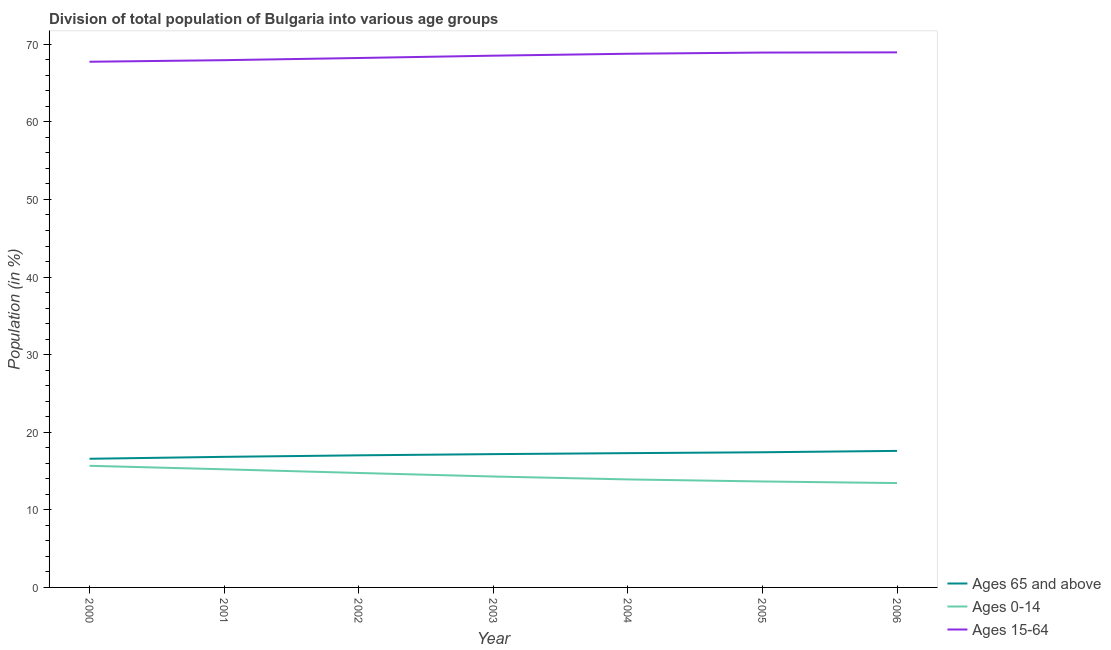Does the line corresponding to percentage of population within the age-group 0-14 intersect with the line corresponding to percentage of population within the age-group 15-64?
Your answer should be compact. No. What is the percentage of population within the age-group 0-14 in 2005?
Your response must be concise. 13.65. Across all years, what is the maximum percentage of population within the age-group of 65 and above?
Provide a short and direct response. 17.6. Across all years, what is the minimum percentage of population within the age-group of 65 and above?
Your response must be concise. 16.58. In which year was the percentage of population within the age-group 0-14 maximum?
Your answer should be very brief. 2000. What is the total percentage of population within the age-group 0-14 in the graph?
Offer a terse response. 100.96. What is the difference between the percentage of population within the age-group 0-14 in 2004 and that in 2006?
Your response must be concise. 0.47. What is the difference between the percentage of population within the age-group 0-14 in 2004 and the percentage of population within the age-group of 65 and above in 2000?
Your answer should be very brief. -2.66. What is the average percentage of population within the age-group of 65 and above per year?
Give a very brief answer. 17.13. In the year 2001, what is the difference between the percentage of population within the age-group 0-14 and percentage of population within the age-group of 65 and above?
Your response must be concise. -1.61. In how many years, is the percentage of population within the age-group 0-14 greater than 48 %?
Your answer should be compact. 0. What is the ratio of the percentage of population within the age-group 15-64 in 2003 to that in 2006?
Offer a terse response. 0.99. Is the percentage of population within the age-group 15-64 in 2003 less than that in 2004?
Ensure brevity in your answer.  Yes. Is the difference between the percentage of population within the age-group 15-64 in 2000 and 2006 greater than the difference between the percentage of population within the age-group 0-14 in 2000 and 2006?
Offer a very short reply. No. What is the difference between the highest and the second highest percentage of population within the age-group of 65 and above?
Your answer should be compact. 0.18. What is the difference between the highest and the lowest percentage of population within the age-group 0-14?
Your answer should be very brief. 2.22. Is it the case that in every year, the sum of the percentage of population within the age-group of 65 and above and percentage of population within the age-group 0-14 is greater than the percentage of population within the age-group 15-64?
Make the answer very short. No. Is the percentage of population within the age-group 0-14 strictly less than the percentage of population within the age-group of 65 and above over the years?
Your answer should be very brief. Yes. How many lines are there?
Your answer should be very brief. 3. How many years are there in the graph?
Offer a terse response. 7. What is the difference between two consecutive major ticks on the Y-axis?
Provide a short and direct response. 10. Are the values on the major ticks of Y-axis written in scientific E-notation?
Make the answer very short. No. What is the title of the graph?
Provide a short and direct response. Division of total population of Bulgaria into various age groups
. Does "Manufactures" appear as one of the legend labels in the graph?
Your answer should be very brief. No. What is the label or title of the X-axis?
Your answer should be very brief. Year. What is the Population (in %) in Ages 65 and above in 2000?
Ensure brevity in your answer.  16.58. What is the Population (in %) in Ages 0-14 in 2000?
Provide a short and direct response. 15.67. What is the Population (in %) in Ages 15-64 in 2000?
Offer a very short reply. 67.74. What is the Population (in %) of Ages 65 and above in 2001?
Your response must be concise. 16.83. What is the Population (in %) of Ages 0-14 in 2001?
Make the answer very short. 15.22. What is the Population (in %) of Ages 15-64 in 2001?
Ensure brevity in your answer.  67.95. What is the Population (in %) in Ages 65 and above in 2002?
Your answer should be compact. 17.02. What is the Population (in %) in Ages 0-14 in 2002?
Offer a terse response. 14.75. What is the Population (in %) of Ages 15-64 in 2002?
Provide a succinct answer. 68.23. What is the Population (in %) of Ages 65 and above in 2003?
Provide a succinct answer. 17.18. What is the Population (in %) in Ages 0-14 in 2003?
Keep it short and to the point. 14.29. What is the Population (in %) of Ages 15-64 in 2003?
Provide a succinct answer. 68.53. What is the Population (in %) in Ages 65 and above in 2004?
Keep it short and to the point. 17.31. What is the Population (in %) of Ages 0-14 in 2004?
Your answer should be very brief. 13.92. What is the Population (in %) of Ages 15-64 in 2004?
Offer a terse response. 68.78. What is the Population (in %) of Ages 65 and above in 2005?
Make the answer very short. 17.42. What is the Population (in %) in Ages 0-14 in 2005?
Keep it short and to the point. 13.65. What is the Population (in %) in Ages 15-64 in 2005?
Your answer should be compact. 68.93. What is the Population (in %) of Ages 65 and above in 2006?
Your answer should be compact. 17.6. What is the Population (in %) of Ages 0-14 in 2006?
Keep it short and to the point. 13.45. What is the Population (in %) in Ages 15-64 in 2006?
Keep it short and to the point. 68.95. Across all years, what is the maximum Population (in %) in Ages 65 and above?
Your response must be concise. 17.6. Across all years, what is the maximum Population (in %) in Ages 0-14?
Offer a very short reply. 15.67. Across all years, what is the maximum Population (in %) in Ages 15-64?
Your answer should be very brief. 68.95. Across all years, what is the minimum Population (in %) in Ages 65 and above?
Make the answer very short. 16.58. Across all years, what is the minimum Population (in %) in Ages 0-14?
Offer a terse response. 13.45. Across all years, what is the minimum Population (in %) in Ages 15-64?
Your answer should be very brief. 67.74. What is the total Population (in %) of Ages 65 and above in the graph?
Provide a succinct answer. 119.93. What is the total Population (in %) of Ages 0-14 in the graph?
Your response must be concise. 100.96. What is the total Population (in %) in Ages 15-64 in the graph?
Your answer should be very brief. 479.11. What is the difference between the Population (in %) in Ages 65 and above in 2000 and that in 2001?
Your response must be concise. -0.25. What is the difference between the Population (in %) of Ages 0-14 in 2000 and that in 2001?
Your answer should be compact. 0.45. What is the difference between the Population (in %) in Ages 15-64 in 2000 and that in 2001?
Ensure brevity in your answer.  -0.2. What is the difference between the Population (in %) of Ages 65 and above in 2000 and that in 2002?
Your response must be concise. -0.44. What is the difference between the Population (in %) of Ages 0-14 in 2000 and that in 2002?
Keep it short and to the point. 0.92. What is the difference between the Population (in %) in Ages 15-64 in 2000 and that in 2002?
Provide a short and direct response. -0.48. What is the difference between the Population (in %) in Ages 65 and above in 2000 and that in 2003?
Provide a succinct answer. -0.6. What is the difference between the Population (in %) in Ages 0-14 in 2000 and that in 2003?
Make the answer very short. 1.38. What is the difference between the Population (in %) of Ages 15-64 in 2000 and that in 2003?
Offer a very short reply. -0.78. What is the difference between the Population (in %) in Ages 65 and above in 2000 and that in 2004?
Provide a succinct answer. -0.72. What is the difference between the Population (in %) of Ages 0-14 in 2000 and that in 2004?
Keep it short and to the point. 1.75. What is the difference between the Population (in %) in Ages 15-64 in 2000 and that in 2004?
Keep it short and to the point. -1.03. What is the difference between the Population (in %) in Ages 65 and above in 2000 and that in 2005?
Provide a succinct answer. -0.84. What is the difference between the Population (in %) of Ages 0-14 in 2000 and that in 2005?
Make the answer very short. 2.02. What is the difference between the Population (in %) in Ages 15-64 in 2000 and that in 2005?
Offer a terse response. -1.18. What is the difference between the Population (in %) of Ages 65 and above in 2000 and that in 2006?
Your response must be concise. -1.01. What is the difference between the Population (in %) of Ages 0-14 in 2000 and that in 2006?
Provide a succinct answer. 2.22. What is the difference between the Population (in %) in Ages 15-64 in 2000 and that in 2006?
Keep it short and to the point. -1.21. What is the difference between the Population (in %) of Ages 65 and above in 2001 and that in 2002?
Offer a terse response. -0.19. What is the difference between the Population (in %) of Ages 0-14 in 2001 and that in 2002?
Give a very brief answer. 0.47. What is the difference between the Population (in %) of Ages 15-64 in 2001 and that in 2002?
Your response must be concise. -0.28. What is the difference between the Population (in %) in Ages 65 and above in 2001 and that in 2003?
Offer a terse response. -0.35. What is the difference between the Population (in %) in Ages 0-14 in 2001 and that in 2003?
Offer a terse response. 0.93. What is the difference between the Population (in %) of Ages 15-64 in 2001 and that in 2003?
Provide a short and direct response. -0.58. What is the difference between the Population (in %) of Ages 65 and above in 2001 and that in 2004?
Keep it short and to the point. -0.48. What is the difference between the Population (in %) in Ages 0-14 in 2001 and that in 2004?
Ensure brevity in your answer.  1.3. What is the difference between the Population (in %) of Ages 15-64 in 2001 and that in 2004?
Your answer should be very brief. -0.83. What is the difference between the Population (in %) of Ages 65 and above in 2001 and that in 2005?
Provide a short and direct response. -0.59. What is the difference between the Population (in %) in Ages 0-14 in 2001 and that in 2005?
Your response must be concise. 1.57. What is the difference between the Population (in %) in Ages 15-64 in 2001 and that in 2005?
Provide a short and direct response. -0.98. What is the difference between the Population (in %) in Ages 65 and above in 2001 and that in 2006?
Provide a succinct answer. -0.77. What is the difference between the Population (in %) of Ages 0-14 in 2001 and that in 2006?
Your answer should be compact. 1.77. What is the difference between the Population (in %) of Ages 15-64 in 2001 and that in 2006?
Provide a succinct answer. -1.01. What is the difference between the Population (in %) of Ages 65 and above in 2002 and that in 2003?
Provide a succinct answer. -0.16. What is the difference between the Population (in %) in Ages 0-14 in 2002 and that in 2003?
Keep it short and to the point. 0.46. What is the difference between the Population (in %) of Ages 15-64 in 2002 and that in 2003?
Provide a succinct answer. -0.3. What is the difference between the Population (in %) in Ages 65 and above in 2002 and that in 2004?
Your answer should be compact. -0.28. What is the difference between the Population (in %) in Ages 0-14 in 2002 and that in 2004?
Offer a terse response. 0.83. What is the difference between the Population (in %) of Ages 15-64 in 2002 and that in 2004?
Offer a very short reply. -0.55. What is the difference between the Population (in %) of Ages 65 and above in 2002 and that in 2005?
Offer a terse response. -0.4. What is the difference between the Population (in %) of Ages 0-14 in 2002 and that in 2005?
Offer a terse response. 1.1. What is the difference between the Population (in %) of Ages 15-64 in 2002 and that in 2005?
Your answer should be compact. -0.7. What is the difference between the Population (in %) of Ages 65 and above in 2002 and that in 2006?
Your answer should be very brief. -0.57. What is the difference between the Population (in %) in Ages 0-14 in 2002 and that in 2006?
Your response must be concise. 1.3. What is the difference between the Population (in %) in Ages 15-64 in 2002 and that in 2006?
Provide a succinct answer. -0.73. What is the difference between the Population (in %) in Ages 65 and above in 2003 and that in 2004?
Your answer should be compact. -0.13. What is the difference between the Population (in %) in Ages 0-14 in 2003 and that in 2004?
Your answer should be very brief. 0.38. What is the difference between the Population (in %) in Ages 15-64 in 2003 and that in 2004?
Your response must be concise. -0.25. What is the difference between the Population (in %) of Ages 65 and above in 2003 and that in 2005?
Give a very brief answer. -0.24. What is the difference between the Population (in %) of Ages 0-14 in 2003 and that in 2005?
Provide a short and direct response. 0.64. What is the difference between the Population (in %) of Ages 15-64 in 2003 and that in 2005?
Your answer should be very brief. -0.4. What is the difference between the Population (in %) in Ages 65 and above in 2003 and that in 2006?
Your answer should be compact. -0.42. What is the difference between the Population (in %) in Ages 0-14 in 2003 and that in 2006?
Give a very brief answer. 0.85. What is the difference between the Population (in %) in Ages 15-64 in 2003 and that in 2006?
Your response must be concise. -0.43. What is the difference between the Population (in %) in Ages 65 and above in 2004 and that in 2005?
Provide a succinct answer. -0.11. What is the difference between the Population (in %) in Ages 0-14 in 2004 and that in 2005?
Offer a very short reply. 0.26. What is the difference between the Population (in %) in Ages 15-64 in 2004 and that in 2005?
Your answer should be very brief. -0.15. What is the difference between the Population (in %) in Ages 65 and above in 2004 and that in 2006?
Your answer should be compact. -0.29. What is the difference between the Population (in %) in Ages 0-14 in 2004 and that in 2006?
Keep it short and to the point. 0.47. What is the difference between the Population (in %) of Ages 15-64 in 2004 and that in 2006?
Offer a very short reply. -0.18. What is the difference between the Population (in %) of Ages 65 and above in 2005 and that in 2006?
Provide a succinct answer. -0.18. What is the difference between the Population (in %) in Ages 0-14 in 2005 and that in 2006?
Provide a succinct answer. 0.2. What is the difference between the Population (in %) of Ages 15-64 in 2005 and that in 2006?
Offer a very short reply. -0.03. What is the difference between the Population (in %) in Ages 65 and above in 2000 and the Population (in %) in Ages 0-14 in 2001?
Make the answer very short. 1.36. What is the difference between the Population (in %) in Ages 65 and above in 2000 and the Population (in %) in Ages 15-64 in 2001?
Provide a short and direct response. -51.37. What is the difference between the Population (in %) in Ages 0-14 in 2000 and the Population (in %) in Ages 15-64 in 2001?
Your answer should be very brief. -52.27. What is the difference between the Population (in %) of Ages 65 and above in 2000 and the Population (in %) of Ages 0-14 in 2002?
Your answer should be very brief. 1.83. What is the difference between the Population (in %) in Ages 65 and above in 2000 and the Population (in %) in Ages 15-64 in 2002?
Give a very brief answer. -51.65. What is the difference between the Population (in %) in Ages 0-14 in 2000 and the Population (in %) in Ages 15-64 in 2002?
Offer a very short reply. -52.55. What is the difference between the Population (in %) of Ages 65 and above in 2000 and the Population (in %) of Ages 0-14 in 2003?
Make the answer very short. 2.29. What is the difference between the Population (in %) in Ages 65 and above in 2000 and the Population (in %) in Ages 15-64 in 2003?
Your answer should be very brief. -51.95. What is the difference between the Population (in %) in Ages 0-14 in 2000 and the Population (in %) in Ages 15-64 in 2003?
Offer a terse response. -52.85. What is the difference between the Population (in %) of Ages 65 and above in 2000 and the Population (in %) of Ages 0-14 in 2004?
Your answer should be compact. 2.66. What is the difference between the Population (in %) in Ages 65 and above in 2000 and the Population (in %) in Ages 15-64 in 2004?
Make the answer very short. -52.19. What is the difference between the Population (in %) of Ages 0-14 in 2000 and the Population (in %) of Ages 15-64 in 2004?
Your response must be concise. -53.1. What is the difference between the Population (in %) in Ages 65 and above in 2000 and the Population (in %) in Ages 0-14 in 2005?
Provide a succinct answer. 2.93. What is the difference between the Population (in %) of Ages 65 and above in 2000 and the Population (in %) of Ages 15-64 in 2005?
Your answer should be very brief. -52.35. What is the difference between the Population (in %) of Ages 0-14 in 2000 and the Population (in %) of Ages 15-64 in 2005?
Provide a succinct answer. -53.25. What is the difference between the Population (in %) of Ages 65 and above in 2000 and the Population (in %) of Ages 0-14 in 2006?
Offer a terse response. 3.13. What is the difference between the Population (in %) of Ages 65 and above in 2000 and the Population (in %) of Ages 15-64 in 2006?
Offer a terse response. -52.37. What is the difference between the Population (in %) in Ages 0-14 in 2000 and the Population (in %) in Ages 15-64 in 2006?
Make the answer very short. -53.28. What is the difference between the Population (in %) of Ages 65 and above in 2001 and the Population (in %) of Ages 0-14 in 2002?
Keep it short and to the point. 2.08. What is the difference between the Population (in %) of Ages 65 and above in 2001 and the Population (in %) of Ages 15-64 in 2002?
Ensure brevity in your answer.  -51.4. What is the difference between the Population (in %) in Ages 0-14 in 2001 and the Population (in %) in Ages 15-64 in 2002?
Your response must be concise. -53. What is the difference between the Population (in %) of Ages 65 and above in 2001 and the Population (in %) of Ages 0-14 in 2003?
Your response must be concise. 2.53. What is the difference between the Population (in %) of Ages 65 and above in 2001 and the Population (in %) of Ages 15-64 in 2003?
Keep it short and to the point. -51.7. What is the difference between the Population (in %) in Ages 0-14 in 2001 and the Population (in %) in Ages 15-64 in 2003?
Your answer should be very brief. -53.3. What is the difference between the Population (in %) of Ages 65 and above in 2001 and the Population (in %) of Ages 0-14 in 2004?
Give a very brief answer. 2.91. What is the difference between the Population (in %) in Ages 65 and above in 2001 and the Population (in %) in Ages 15-64 in 2004?
Give a very brief answer. -51.95. What is the difference between the Population (in %) in Ages 0-14 in 2001 and the Population (in %) in Ages 15-64 in 2004?
Ensure brevity in your answer.  -53.55. What is the difference between the Population (in %) in Ages 65 and above in 2001 and the Population (in %) in Ages 0-14 in 2005?
Offer a terse response. 3.17. What is the difference between the Population (in %) in Ages 65 and above in 2001 and the Population (in %) in Ages 15-64 in 2005?
Provide a short and direct response. -52.1. What is the difference between the Population (in %) in Ages 0-14 in 2001 and the Population (in %) in Ages 15-64 in 2005?
Offer a terse response. -53.71. What is the difference between the Population (in %) of Ages 65 and above in 2001 and the Population (in %) of Ages 0-14 in 2006?
Keep it short and to the point. 3.38. What is the difference between the Population (in %) of Ages 65 and above in 2001 and the Population (in %) of Ages 15-64 in 2006?
Give a very brief answer. -52.13. What is the difference between the Population (in %) of Ages 0-14 in 2001 and the Population (in %) of Ages 15-64 in 2006?
Keep it short and to the point. -53.73. What is the difference between the Population (in %) in Ages 65 and above in 2002 and the Population (in %) in Ages 0-14 in 2003?
Provide a short and direct response. 2.73. What is the difference between the Population (in %) of Ages 65 and above in 2002 and the Population (in %) of Ages 15-64 in 2003?
Offer a terse response. -51.5. What is the difference between the Population (in %) of Ages 0-14 in 2002 and the Population (in %) of Ages 15-64 in 2003?
Offer a very short reply. -53.78. What is the difference between the Population (in %) of Ages 65 and above in 2002 and the Population (in %) of Ages 0-14 in 2004?
Give a very brief answer. 3.1. What is the difference between the Population (in %) in Ages 65 and above in 2002 and the Population (in %) in Ages 15-64 in 2004?
Ensure brevity in your answer.  -51.75. What is the difference between the Population (in %) of Ages 0-14 in 2002 and the Population (in %) of Ages 15-64 in 2004?
Provide a succinct answer. -54.03. What is the difference between the Population (in %) in Ages 65 and above in 2002 and the Population (in %) in Ages 0-14 in 2005?
Ensure brevity in your answer.  3.37. What is the difference between the Population (in %) of Ages 65 and above in 2002 and the Population (in %) of Ages 15-64 in 2005?
Your answer should be compact. -51.91. What is the difference between the Population (in %) in Ages 0-14 in 2002 and the Population (in %) in Ages 15-64 in 2005?
Offer a very short reply. -54.18. What is the difference between the Population (in %) in Ages 65 and above in 2002 and the Population (in %) in Ages 0-14 in 2006?
Your response must be concise. 3.57. What is the difference between the Population (in %) in Ages 65 and above in 2002 and the Population (in %) in Ages 15-64 in 2006?
Offer a terse response. -51.93. What is the difference between the Population (in %) in Ages 0-14 in 2002 and the Population (in %) in Ages 15-64 in 2006?
Offer a terse response. -54.2. What is the difference between the Population (in %) in Ages 65 and above in 2003 and the Population (in %) in Ages 0-14 in 2004?
Your answer should be very brief. 3.26. What is the difference between the Population (in %) of Ages 65 and above in 2003 and the Population (in %) of Ages 15-64 in 2004?
Your answer should be very brief. -51.6. What is the difference between the Population (in %) of Ages 0-14 in 2003 and the Population (in %) of Ages 15-64 in 2004?
Your answer should be very brief. -54.48. What is the difference between the Population (in %) of Ages 65 and above in 2003 and the Population (in %) of Ages 0-14 in 2005?
Make the answer very short. 3.52. What is the difference between the Population (in %) of Ages 65 and above in 2003 and the Population (in %) of Ages 15-64 in 2005?
Offer a very short reply. -51.75. What is the difference between the Population (in %) of Ages 0-14 in 2003 and the Population (in %) of Ages 15-64 in 2005?
Ensure brevity in your answer.  -54.63. What is the difference between the Population (in %) in Ages 65 and above in 2003 and the Population (in %) in Ages 0-14 in 2006?
Ensure brevity in your answer.  3.73. What is the difference between the Population (in %) of Ages 65 and above in 2003 and the Population (in %) of Ages 15-64 in 2006?
Offer a terse response. -51.78. What is the difference between the Population (in %) in Ages 0-14 in 2003 and the Population (in %) in Ages 15-64 in 2006?
Offer a terse response. -54.66. What is the difference between the Population (in %) of Ages 65 and above in 2004 and the Population (in %) of Ages 0-14 in 2005?
Your answer should be very brief. 3.65. What is the difference between the Population (in %) of Ages 65 and above in 2004 and the Population (in %) of Ages 15-64 in 2005?
Give a very brief answer. -51.62. What is the difference between the Population (in %) of Ages 0-14 in 2004 and the Population (in %) of Ages 15-64 in 2005?
Ensure brevity in your answer.  -55.01. What is the difference between the Population (in %) of Ages 65 and above in 2004 and the Population (in %) of Ages 0-14 in 2006?
Provide a short and direct response. 3.86. What is the difference between the Population (in %) of Ages 65 and above in 2004 and the Population (in %) of Ages 15-64 in 2006?
Make the answer very short. -51.65. What is the difference between the Population (in %) in Ages 0-14 in 2004 and the Population (in %) in Ages 15-64 in 2006?
Your answer should be compact. -55.04. What is the difference between the Population (in %) of Ages 65 and above in 2005 and the Population (in %) of Ages 0-14 in 2006?
Offer a very short reply. 3.97. What is the difference between the Population (in %) in Ages 65 and above in 2005 and the Population (in %) in Ages 15-64 in 2006?
Give a very brief answer. -51.54. What is the difference between the Population (in %) in Ages 0-14 in 2005 and the Population (in %) in Ages 15-64 in 2006?
Offer a terse response. -55.3. What is the average Population (in %) of Ages 65 and above per year?
Provide a short and direct response. 17.13. What is the average Population (in %) of Ages 0-14 per year?
Offer a terse response. 14.42. What is the average Population (in %) in Ages 15-64 per year?
Your response must be concise. 68.44. In the year 2000, what is the difference between the Population (in %) in Ages 65 and above and Population (in %) in Ages 0-14?
Your answer should be very brief. 0.91. In the year 2000, what is the difference between the Population (in %) of Ages 65 and above and Population (in %) of Ages 15-64?
Your response must be concise. -51.16. In the year 2000, what is the difference between the Population (in %) in Ages 0-14 and Population (in %) in Ages 15-64?
Your answer should be compact. -52.07. In the year 2001, what is the difference between the Population (in %) of Ages 65 and above and Population (in %) of Ages 0-14?
Offer a very short reply. 1.61. In the year 2001, what is the difference between the Population (in %) in Ages 65 and above and Population (in %) in Ages 15-64?
Your answer should be compact. -51.12. In the year 2001, what is the difference between the Population (in %) of Ages 0-14 and Population (in %) of Ages 15-64?
Offer a terse response. -52.73. In the year 2002, what is the difference between the Population (in %) of Ages 65 and above and Population (in %) of Ages 0-14?
Your answer should be compact. 2.27. In the year 2002, what is the difference between the Population (in %) of Ages 65 and above and Population (in %) of Ages 15-64?
Offer a very short reply. -51.2. In the year 2002, what is the difference between the Population (in %) in Ages 0-14 and Population (in %) in Ages 15-64?
Your answer should be very brief. -53.48. In the year 2003, what is the difference between the Population (in %) in Ages 65 and above and Population (in %) in Ages 0-14?
Your response must be concise. 2.88. In the year 2003, what is the difference between the Population (in %) in Ages 65 and above and Population (in %) in Ages 15-64?
Make the answer very short. -51.35. In the year 2003, what is the difference between the Population (in %) of Ages 0-14 and Population (in %) of Ages 15-64?
Provide a short and direct response. -54.23. In the year 2004, what is the difference between the Population (in %) in Ages 65 and above and Population (in %) in Ages 0-14?
Keep it short and to the point. 3.39. In the year 2004, what is the difference between the Population (in %) of Ages 65 and above and Population (in %) of Ages 15-64?
Your answer should be very brief. -51.47. In the year 2004, what is the difference between the Population (in %) of Ages 0-14 and Population (in %) of Ages 15-64?
Your answer should be compact. -54.86. In the year 2005, what is the difference between the Population (in %) in Ages 65 and above and Population (in %) in Ages 0-14?
Provide a short and direct response. 3.76. In the year 2005, what is the difference between the Population (in %) in Ages 65 and above and Population (in %) in Ages 15-64?
Make the answer very short. -51.51. In the year 2005, what is the difference between the Population (in %) in Ages 0-14 and Population (in %) in Ages 15-64?
Provide a short and direct response. -55.27. In the year 2006, what is the difference between the Population (in %) of Ages 65 and above and Population (in %) of Ages 0-14?
Offer a terse response. 4.15. In the year 2006, what is the difference between the Population (in %) in Ages 65 and above and Population (in %) in Ages 15-64?
Keep it short and to the point. -51.36. In the year 2006, what is the difference between the Population (in %) in Ages 0-14 and Population (in %) in Ages 15-64?
Your response must be concise. -55.51. What is the ratio of the Population (in %) of Ages 0-14 in 2000 to that in 2001?
Give a very brief answer. 1.03. What is the ratio of the Population (in %) of Ages 15-64 in 2000 to that in 2001?
Provide a succinct answer. 1. What is the ratio of the Population (in %) of Ages 65 and above in 2000 to that in 2002?
Make the answer very short. 0.97. What is the ratio of the Population (in %) of Ages 0-14 in 2000 to that in 2002?
Make the answer very short. 1.06. What is the ratio of the Population (in %) of Ages 15-64 in 2000 to that in 2002?
Make the answer very short. 0.99. What is the ratio of the Population (in %) of Ages 65 and above in 2000 to that in 2003?
Offer a terse response. 0.97. What is the ratio of the Population (in %) in Ages 0-14 in 2000 to that in 2003?
Offer a terse response. 1.1. What is the ratio of the Population (in %) of Ages 15-64 in 2000 to that in 2003?
Provide a short and direct response. 0.99. What is the ratio of the Population (in %) in Ages 65 and above in 2000 to that in 2004?
Your answer should be compact. 0.96. What is the ratio of the Population (in %) in Ages 0-14 in 2000 to that in 2004?
Ensure brevity in your answer.  1.13. What is the ratio of the Population (in %) of Ages 0-14 in 2000 to that in 2005?
Offer a terse response. 1.15. What is the ratio of the Population (in %) in Ages 15-64 in 2000 to that in 2005?
Your answer should be compact. 0.98. What is the ratio of the Population (in %) in Ages 65 and above in 2000 to that in 2006?
Your response must be concise. 0.94. What is the ratio of the Population (in %) of Ages 0-14 in 2000 to that in 2006?
Your answer should be compact. 1.17. What is the ratio of the Population (in %) of Ages 15-64 in 2000 to that in 2006?
Provide a succinct answer. 0.98. What is the ratio of the Population (in %) in Ages 0-14 in 2001 to that in 2002?
Ensure brevity in your answer.  1.03. What is the ratio of the Population (in %) of Ages 65 and above in 2001 to that in 2003?
Your response must be concise. 0.98. What is the ratio of the Population (in %) of Ages 0-14 in 2001 to that in 2003?
Provide a short and direct response. 1.06. What is the ratio of the Population (in %) in Ages 65 and above in 2001 to that in 2004?
Keep it short and to the point. 0.97. What is the ratio of the Population (in %) in Ages 0-14 in 2001 to that in 2004?
Offer a very short reply. 1.09. What is the ratio of the Population (in %) of Ages 15-64 in 2001 to that in 2004?
Give a very brief answer. 0.99. What is the ratio of the Population (in %) in Ages 65 and above in 2001 to that in 2005?
Your response must be concise. 0.97. What is the ratio of the Population (in %) in Ages 0-14 in 2001 to that in 2005?
Keep it short and to the point. 1.11. What is the ratio of the Population (in %) of Ages 15-64 in 2001 to that in 2005?
Your response must be concise. 0.99. What is the ratio of the Population (in %) of Ages 65 and above in 2001 to that in 2006?
Offer a terse response. 0.96. What is the ratio of the Population (in %) in Ages 0-14 in 2001 to that in 2006?
Keep it short and to the point. 1.13. What is the ratio of the Population (in %) of Ages 15-64 in 2001 to that in 2006?
Your answer should be compact. 0.99. What is the ratio of the Population (in %) of Ages 0-14 in 2002 to that in 2003?
Your response must be concise. 1.03. What is the ratio of the Population (in %) in Ages 65 and above in 2002 to that in 2004?
Ensure brevity in your answer.  0.98. What is the ratio of the Population (in %) in Ages 0-14 in 2002 to that in 2004?
Your answer should be compact. 1.06. What is the ratio of the Population (in %) of Ages 15-64 in 2002 to that in 2004?
Offer a terse response. 0.99. What is the ratio of the Population (in %) in Ages 65 and above in 2002 to that in 2005?
Make the answer very short. 0.98. What is the ratio of the Population (in %) of Ages 0-14 in 2002 to that in 2005?
Your answer should be compact. 1.08. What is the ratio of the Population (in %) of Ages 15-64 in 2002 to that in 2005?
Provide a short and direct response. 0.99. What is the ratio of the Population (in %) of Ages 65 and above in 2002 to that in 2006?
Keep it short and to the point. 0.97. What is the ratio of the Population (in %) of Ages 0-14 in 2002 to that in 2006?
Provide a short and direct response. 1.1. What is the ratio of the Population (in %) in Ages 15-64 in 2002 to that in 2006?
Make the answer very short. 0.99. What is the ratio of the Population (in %) in Ages 65 and above in 2003 to that in 2004?
Give a very brief answer. 0.99. What is the ratio of the Population (in %) of Ages 15-64 in 2003 to that in 2004?
Provide a short and direct response. 1. What is the ratio of the Population (in %) in Ages 65 and above in 2003 to that in 2005?
Provide a short and direct response. 0.99. What is the ratio of the Population (in %) of Ages 0-14 in 2003 to that in 2005?
Make the answer very short. 1.05. What is the ratio of the Population (in %) in Ages 65 and above in 2003 to that in 2006?
Offer a very short reply. 0.98. What is the ratio of the Population (in %) in Ages 0-14 in 2003 to that in 2006?
Offer a terse response. 1.06. What is the ratio of the Population (in %) of Ages 65 and above in 2004 to that in 2005?
Offer a very short reply. 0.99. What is the ratio of the Population (in %) in Ages 0-14 in 2004 to that in 2005?
Provide a short and direct response. 1.02. What is the ratio of the Population (in %) in Ages 65 and above in 2004 to that in 2006?
Your answer should be very brief. 0.98. What is the ratio of the Population (in %) of Ages 0-14 in 2004 to that in 2006?
Offer a terse response. 1.03. What is the ratio of the Population (in %) of Ages 15-64 in 2004 to that in 2006?
Give a very brief answer. 1. What is the ratio of the Population (in %) in Ages 0-14 in 2005 to that in 2006?
Offer a very short reply. 1.02. What is the difference between the highest and the second highest Population (in %) of Ages 65 and above?
Keep it short and to the point. 0.18. What is the difference between the highest and the second highest Population (in %) of Ages 0-14?
Provide a short and direct response. 0.45. What is the difference between the highest and the second highest Population (in %) in Ages 15-64?
Offer a very short reply. 0.03. What is the difference between the highest and the lowest Population (in %) of Ages 65 and above?
Your answer should be compact. 1.01. What is the difference between the highest and the lowest Population (in %) in Ages 0-14?
Provide a short and direct response. 2.22. What is the difference between the highest and the lowest Population (in %) in Ages 15-64?
Provide a short and direct response. 1.21. 